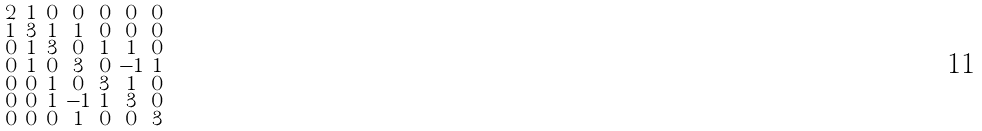<formula> <loc_0><loc_0><loc_500><loc_500>\begin{smallmatrix} 2 & 1 & 0 & 0 & 0 & 0 & 0 \\ 1 & 3 & 1 & 1 & 0 & 0 & 0 \\ 0 & 1 & 3 & 0 & 1 & 1 & 0 \\ 0 & 1 & 0 & 3 & 0 & - 1 & 1 \\ 0 & 0 & 1 & 0 & 3 & 1 & 0 \\ 0 & 0 & 1 & - 1 & 1 & 3 & 0 \\ 0 & 0 & 0 & 1 & 0 & 0 & 3 \end{smallmatrix}</formula> 